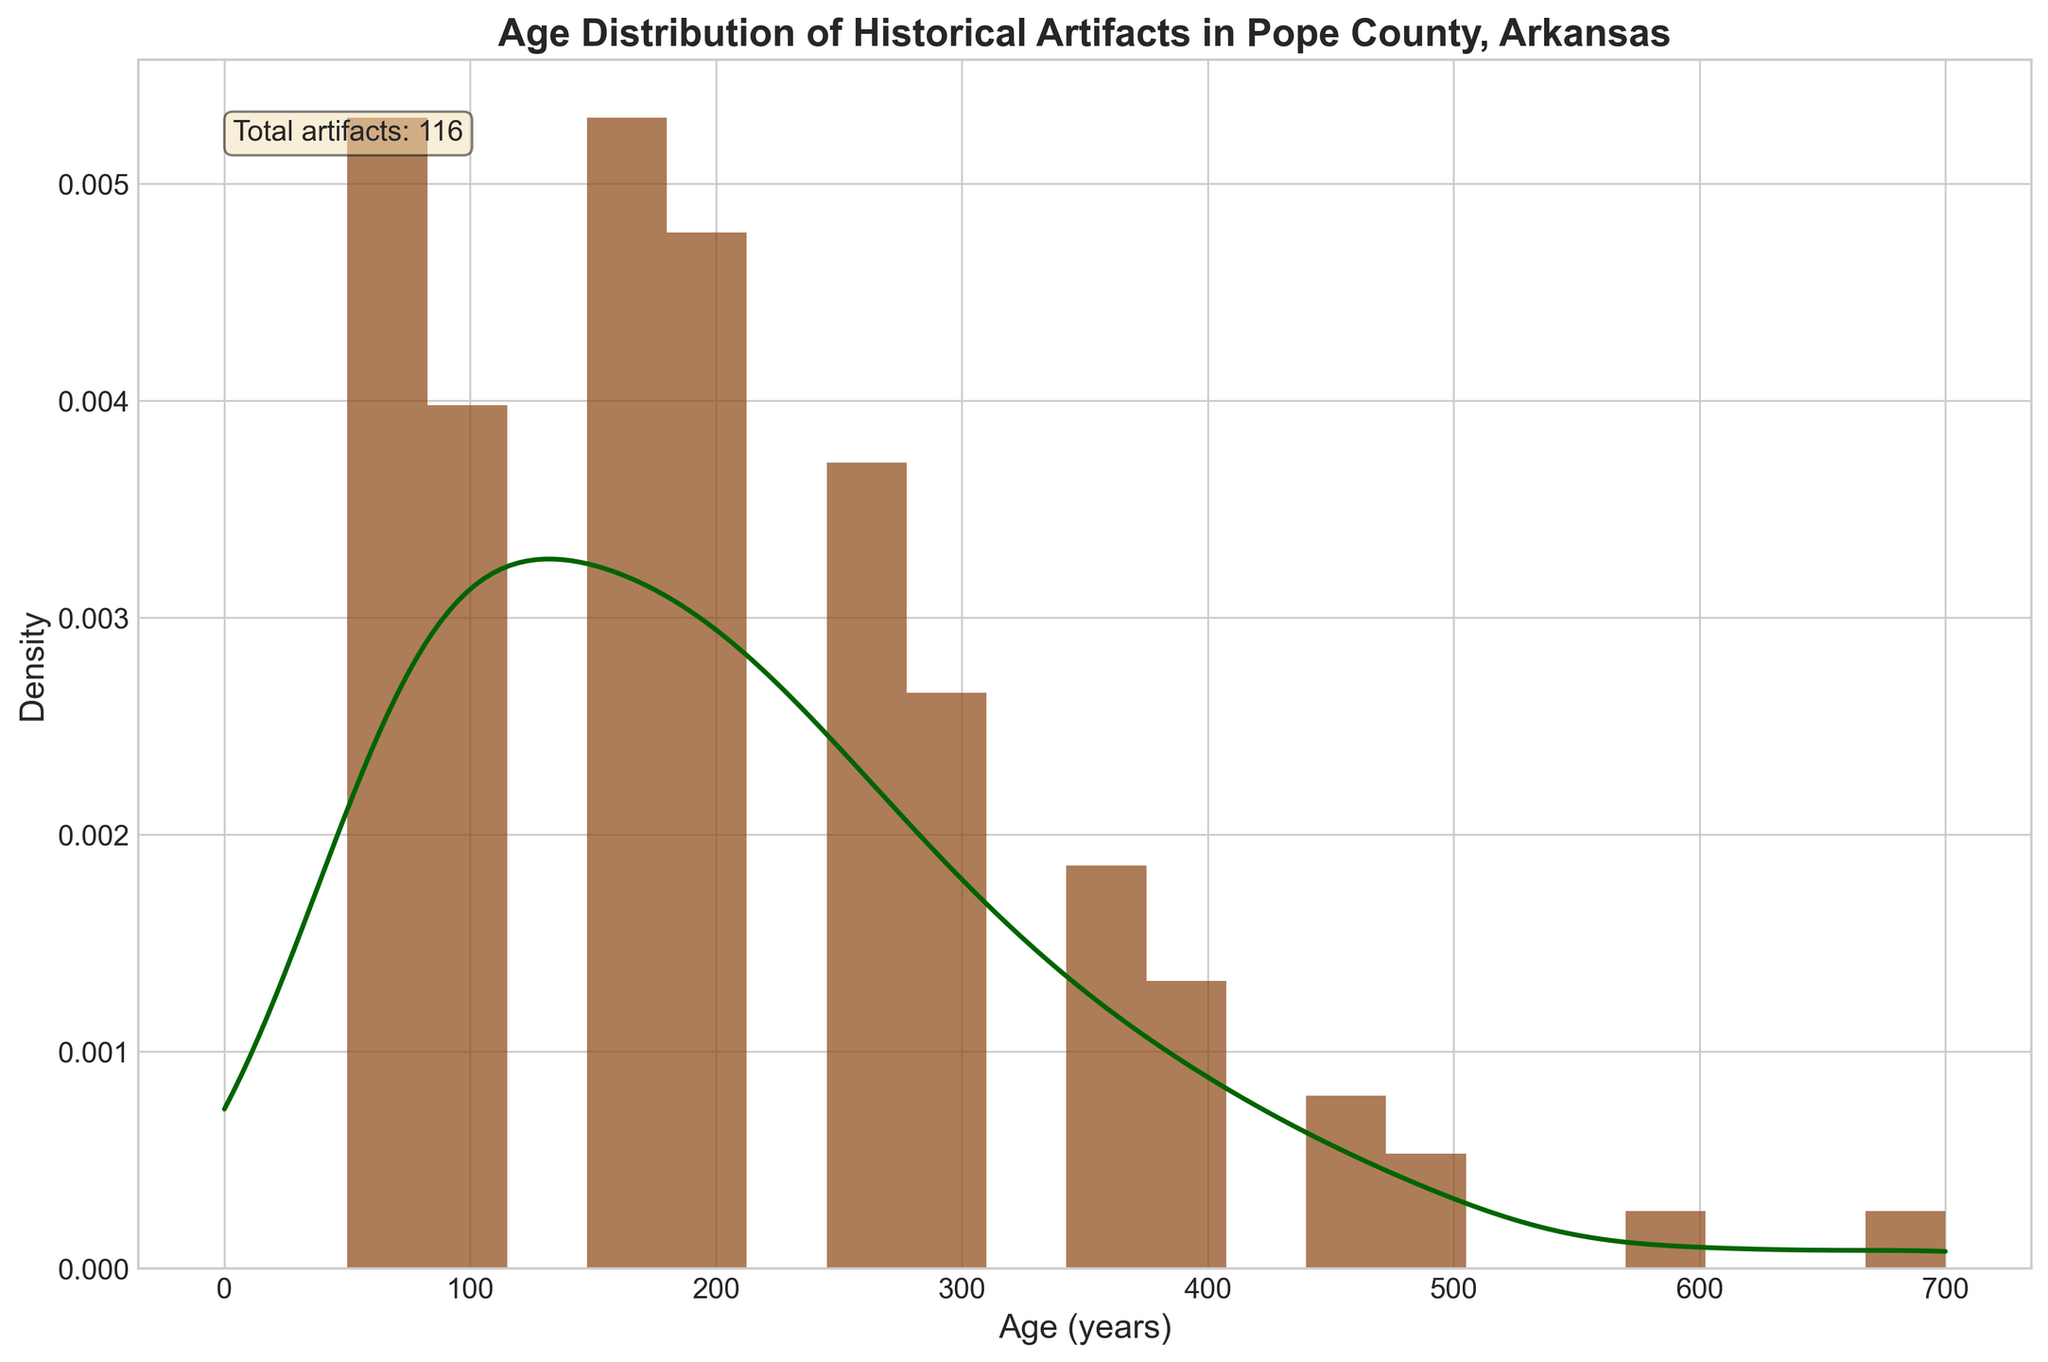What is the title of the figure? The title is located at the top of the figure and is often labeled prominently. In this case, it reads "Age Distribution of Historical Artifacts in Pope County, Arkansas."
Answer: Age Distribution of Historical Artifacts in Pope County, Arkansas What does the x-axis represent in the figure? The x-axis typically labels what the primary variable plotted horizontally represents. Here, it is labeled as "Age (years)," showing the age of the artifacts in years.
Answer: Age (years) How many total artifacts were considered in this histogram? The total number of artifacts can often be found in additional information boxes. Here, the total artifact count is shown in the text box within the figure (Total artifacts: 116).
Answer: 116 Which age group has the highest density of artifacts? By observing the histogram bars and the KDE line, we can determine that the highest density of artifacts is around 150 years.
Answer: Around 150 years How does the KDE (density curve) contribute to understanding the distribution compared to the histogram alone? The KDE smooths out the distribution providing a continuous view, making it easier to see trends, such as peak density points. It complements the histogram by showing the overall shape and smoothing out noisy data from the individual bins.
Answer: It provides a smoothed, continuous view of the distribution What is the approximate density value at 300 years? By looking at the KDE curve's height at 300 years on the x-axis, we can estimate that it is around 0.003 since it appears less pronounced due to the lower count in this age range.
Answer: Around 0.003 Compare the density of artifacts aged 100 years and 200 years. Which is higher? Observing the KDE line, the density at 100 years appears higher, peaking more sharply compared to the density at 200 years.
Answer: 100 years How does the artifact count change as the age increases from 50 years to 700 years? The histogram bars show a general trend: the artifact count peaks between 100 and 200 years, then gradually decreases as the age increases beyond that range.
Answer: Peaks and then decreases Can we identify any significant gaps or intervals with very few artifacts based on the histogram? Yes, the histogram bars indicate smaller gaps where few artifacts exist, notably beyond 400 years, with the count diminishing significantly.
Answer: Beyond 400 years 